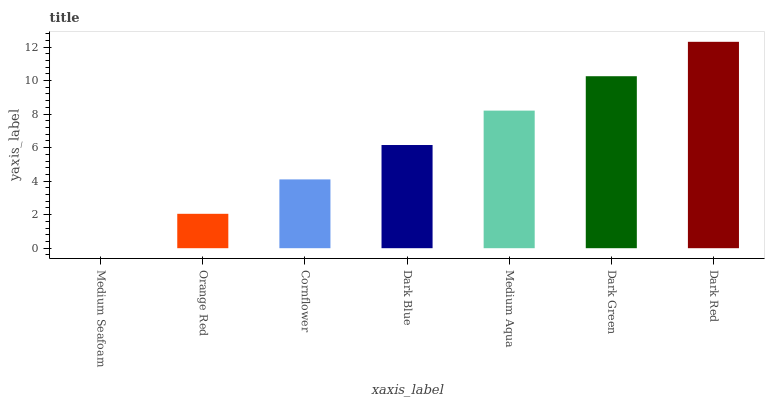Is Orange Red the minimum?
Answer yes or no. No. Is Orange Red the maximum?
Answer yes or no. No. Is Orange Red greater than Medium Seafoam?
Answer yes or no. Yes. Is Medium Seafoam less than Orange Red?
Answer yes or no. Yes. Is Medium Seafoam greater than Orange Red?
Answer yes or no. No. Is Orange Red less than Medium Seafoam?
Answer yes or no. No. Is Dark Blue the high median?
Answer yes or no. Yes. Is Dark Blue the low median?
Answer yes or no. Yes. Is Dark Green the high median?
Answer yes or no. No. Is Dark Green the low median?
Answer yes or no. No. 